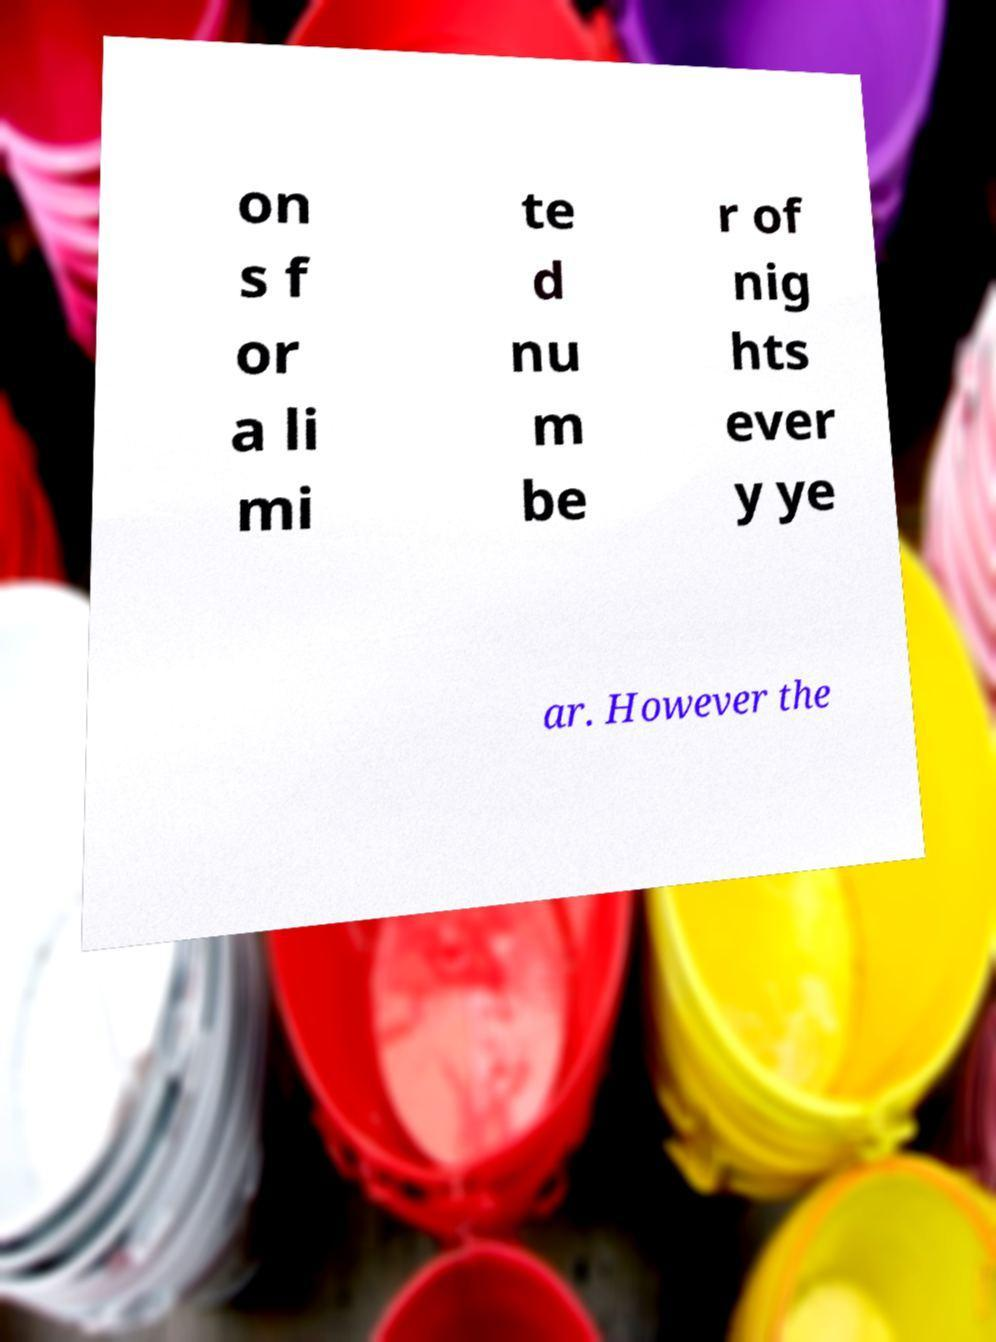There's text embedded in this image that I need extracted. Can you transcribe it verbatim? on s f or a li mi te d nu m be r of nig hts ever y ye ar. However the 